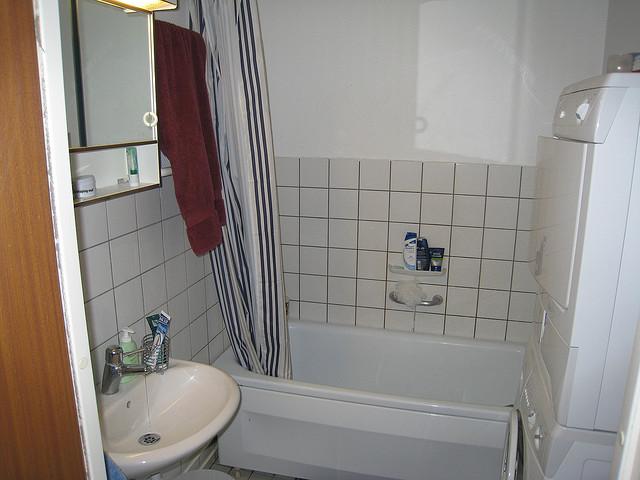What is the name of the shampoo in shower?
Keep it brief. Head and shoulders. What color is the towel?
Keep it brief. Red. What color is the bathtub?
Keep it brief. White. How many square feet is this bathroom?
Write a very short answer. 120. 